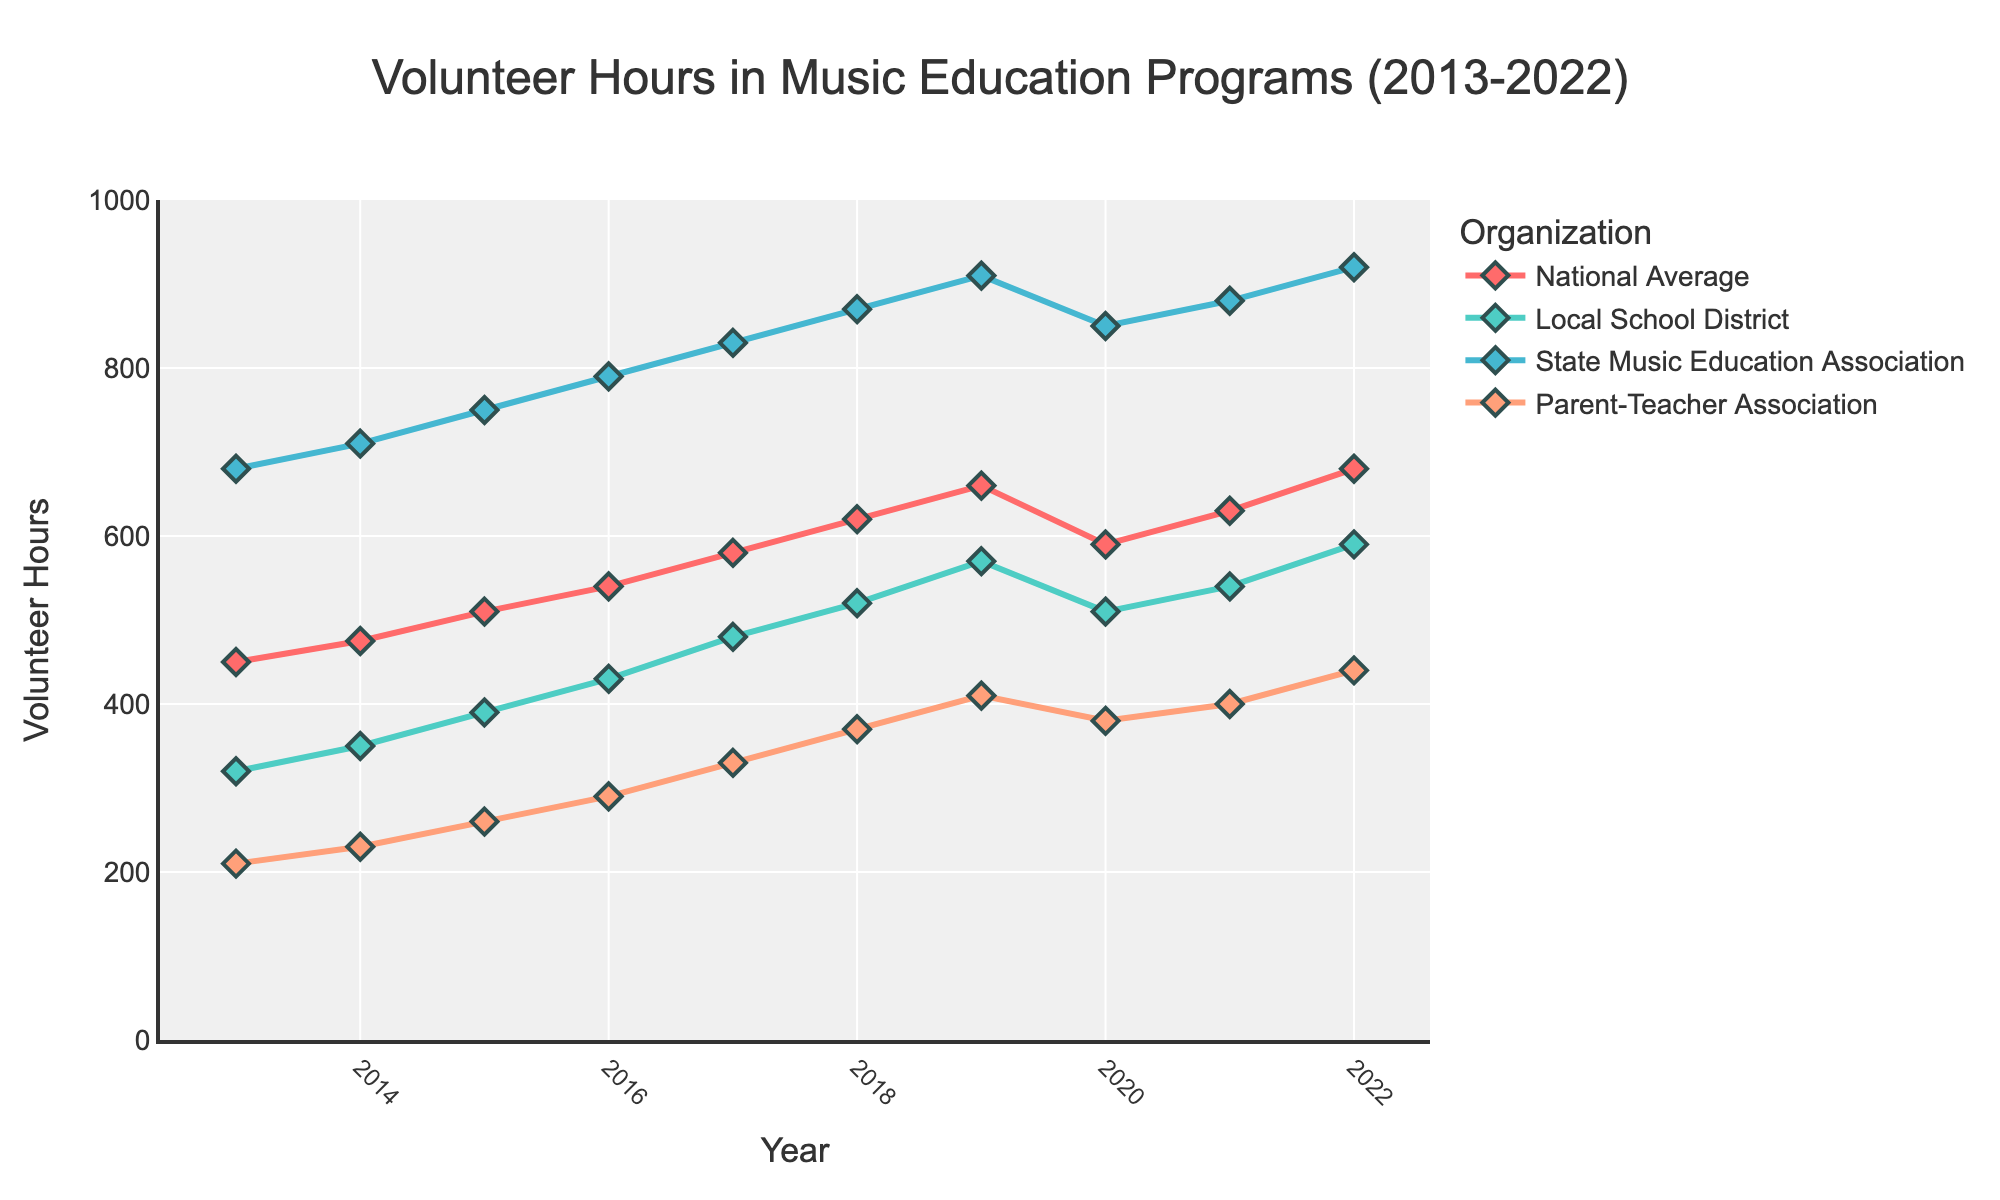What year did the Parent-Teacher Association reach 400 volunteer hours for the first time? The Parent-Teacher Association reached 400 volunteer hours in 2021. This can be seen in the figure where the line for the Parent-Teacher Association intersects the 400-hour mark in that year.
Answer: 2021 Which organization saw the largest increase in volunteer hours between 2013 and 2022? Comparing the volunteer hours for each organization, we can calculate the difference from 2022 and 2013. The National Average increased by 230 hours (680 - 450), the Local School District by 270 hours (590 - 320), the State Music Education Association by 240 hours (920 - 680), and the Parent-Teacher Association by 230 hours (440 - 210). The Local School District saw the largest increase.
Answer: Local School District In which year did the National Average experience a decrease in volunteer hours compared to the previous year? By examining the line for the National Average, it decreased from 660 hours in 2019 to 590 hours in 2020.
Answer: 2020 What was the average number of volunteer hours for the Local School District from 2013 to 2022? Sum the Local School District hours from 2013 to 2022 (320 + 350 + 390 + 430 + 480 + 520 + 570 + 510 + 540 + 590) which equals 4700. There are 10 years in total, so the average is 4700 / 10.
Answer: 470 How many years did the State Music Education Association have more than 800 volunteer hours? By looking at the figure, the State Music Education Association had more than 800 volunteer hours from 2017 to 2022, which is 6 years.
Answer: 6 years Which organization had the highest volunteer hours in 2019? By examining the lines for each organization in 2019, the State Music Education Association had the highest volunteer hours at 910.
Answer: State Music Education Association Did any organization have their volunteer hours drop between 2019 and 2020 besides the National Average? By referring to the figure, the Local School District also saw a drop in volunteer hours between 2019 and 2020, from 570 to 510.
Answer: Local School District What is the trend in volunteer hours for the Parent-Teacher Association from 2013 to 2022, and what might it indicate? We observe a steady increase in volunteer hours for the Parent-Teacher Association from 2013 to 2019, a slight dip in 2020, followed by another increase till 2022. This trend might indicate growing involvement but affected by external factors in 2020.
Answer: Increasing trend with a slight dip in 2020 